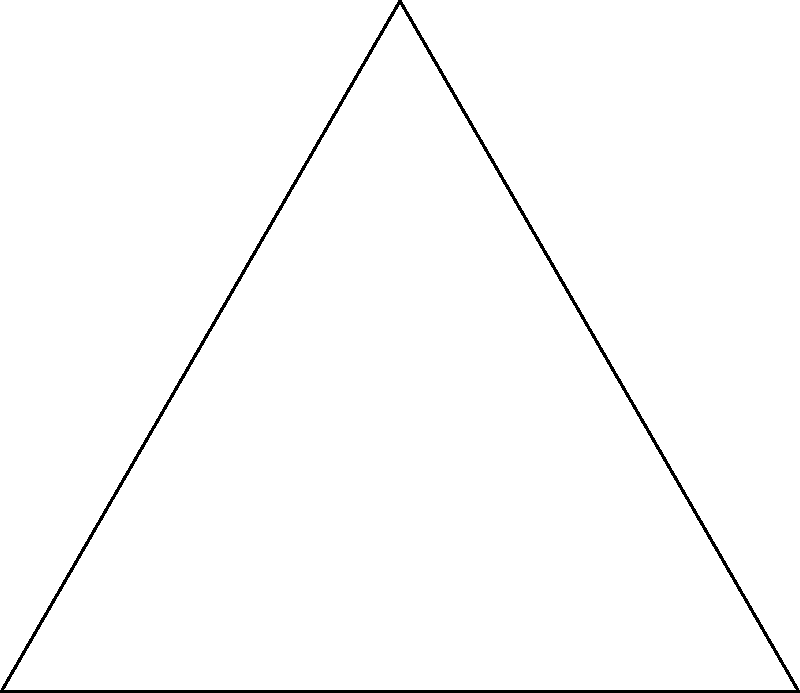Cadillac's prized car has custom wheels with a unique spoke design. The wheel has 6 equally spaced spokes, and you're helping him calculate the angle between each spoke. If the first spoke is at the 3 o'clock position (point A) and the second spoke is at point B, what is the angle of rotation between these spokes? To solve this problem, let's follow these steps:

1) First, recall that a circle has 360°.

2) Since the wheel has 6 equally spaced spokes, we can divide the total degrees in a circle by the number of spokes:

   $$\frac{360°}{6} = 60°$$

3) This means that each spoke is separated by 60°.

4) In the diagram, we can see that point A represents the first spoke at the 3 o'clock position, and point B represents the second spoke.

5) The angle between these two spokes is shown in the diagram as 60°.

Therefore, the angle of rotation between each spoke in Cadillac's custom wheel design is 60°.
Answer: 60° 